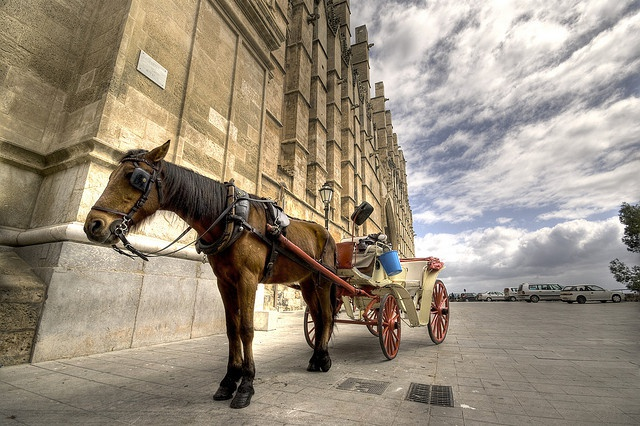Describe the objects in this image and their specific colors. I can see horse in gray, black, and maroon tones, car in gray, black, and darkgray tones, car in gray, black, and darkgray tones, car in gray, darkgray, and black tones, and car in gray, black, and darkgray tones in this image. 